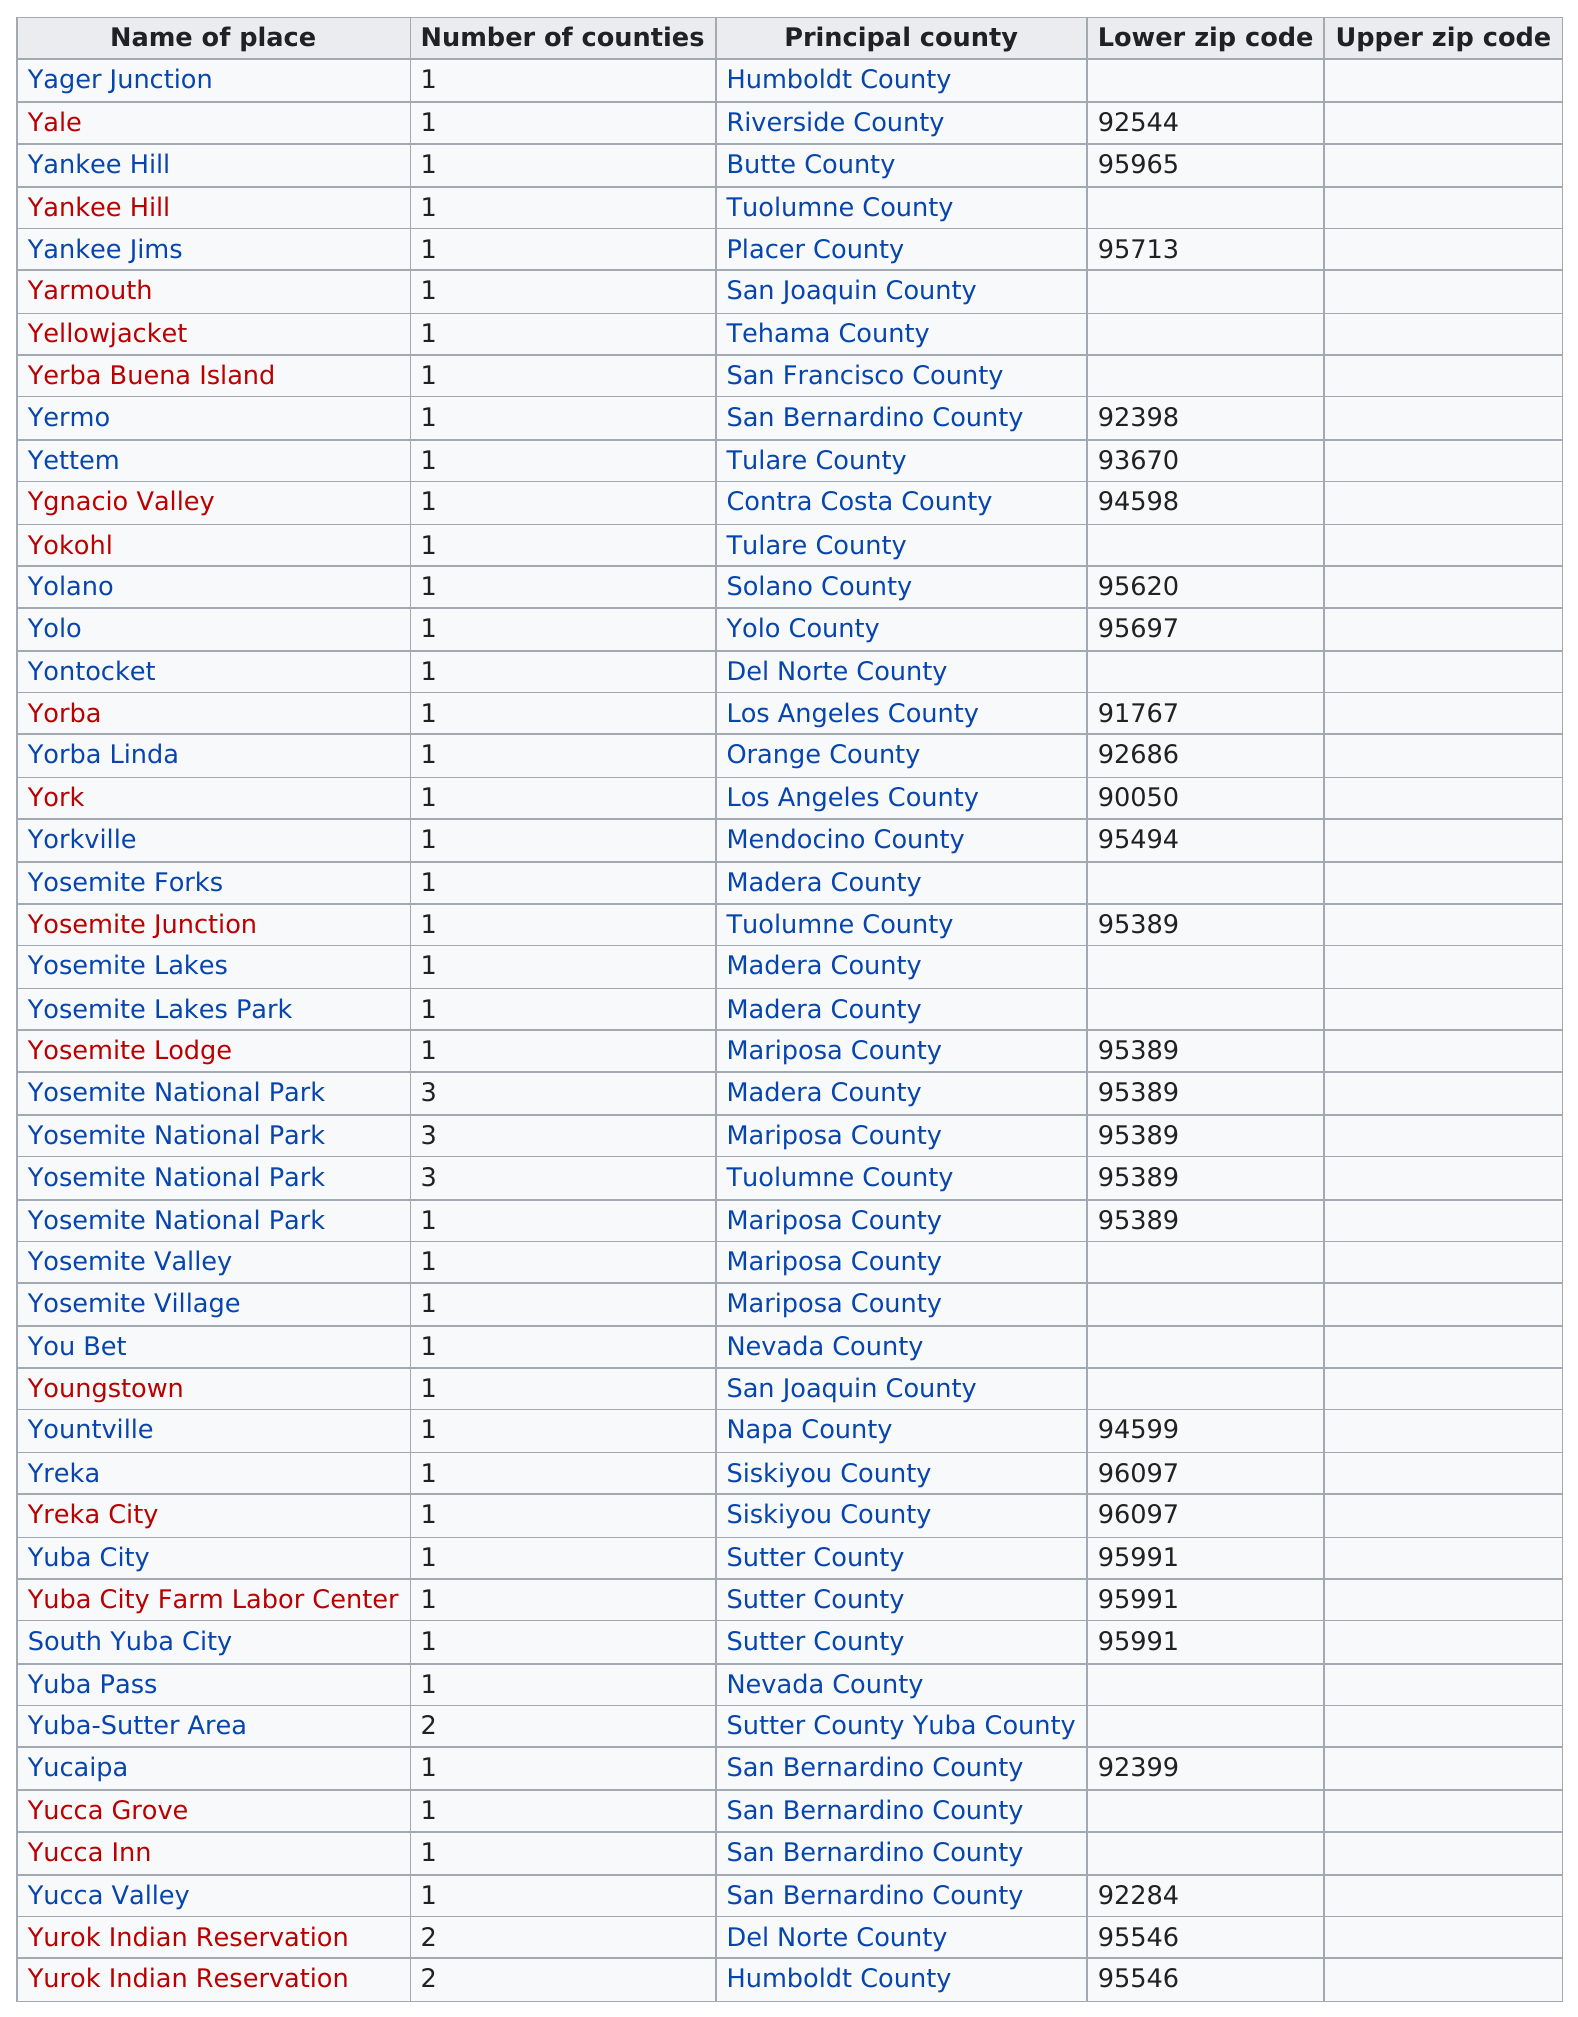Outline some significant characteristics in this image. There are two places that share the same lower zip code as Yosemite National Park. Yurok Indian Reservation is listed as the last place. Six counties have a larger amount than the county in question. The zip code 96097 is shared by Yreka City, and another place. The letter 'Y' is a common element in each of the place names. 